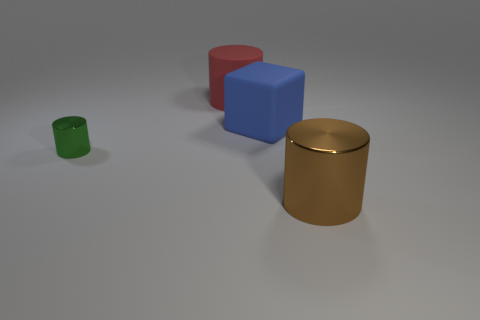Add 2 small red blocks. How many objects exist? 6 Subtract all blocks. How many objects are left? 3 Add 2 brown objects. How many brown objects exist? 3 Subtract 0 cyan cylinders. How many objects are left? 4 Subtract all blue rubber blocks. Subtract all large gray shiny balls. How many objects are left? 3 Add 2 large blue matte objects. How many large blue matte objects are left? 3 